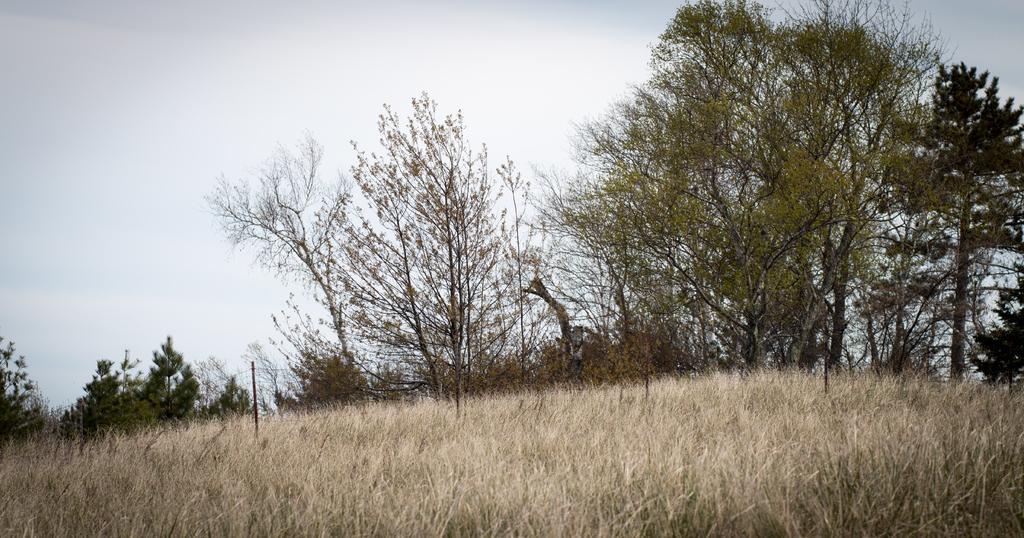Describe this image in one or two sentences. As we can see in the image there is dry grass, pole and trees. At the top there is sky. 